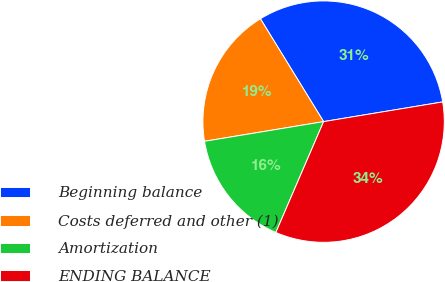Convert chart to OTSL. <chart><loc_0><loc_0><loc_500><loc_500><pie_chart><fcel>Beginning balance<fcel>Costs deferred and other (1)<fcel>Amortization<fcel>ENDING BALANCE<nl><fcel>31.16%<fcel>18.84%<fcel>15.92%<fcel>34.08%<nl></chart> 